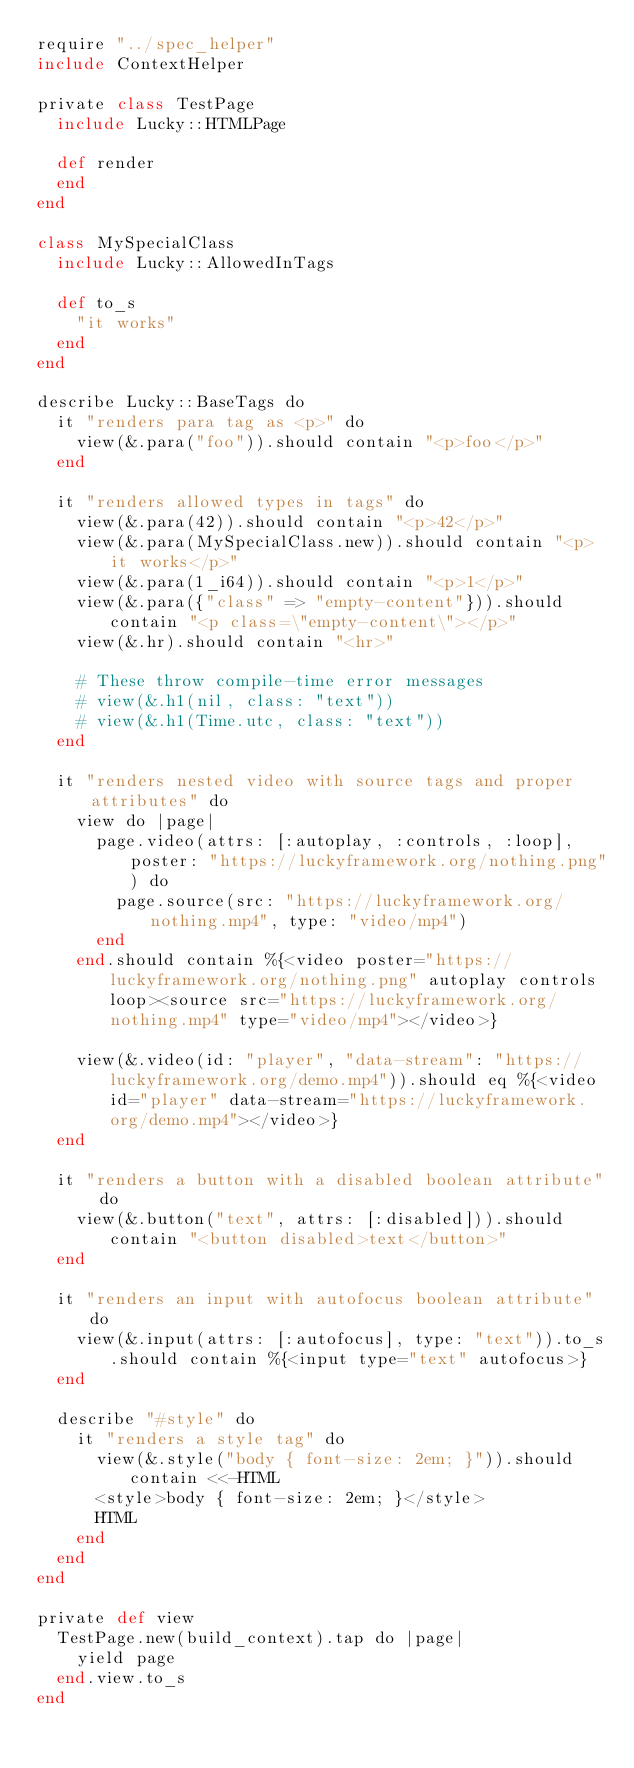<code> <loc_0><loc_0><loc_500><loc_500><_Crystal_>require "../spec_helper"
include ContextHelper

private class TestPage
  include Lucky::HTMLPage

  def render
  end
end

class MySpecialClass
  include Lucky::AllowedInTags

  def to_s
    "it works"
  end
end

describe Lucky::BaseTags do
  it "renders para tag as <p>" do
    view(&.para("foo")).should contain "<p>foo</p>"
  end

  it "renders allowed types in tags" do
    view(&.para(42)).should contain "<p>42</p>"
    view(&.para(MySpecialClass.new)).should contain "<p>it works</p>"
    view(&.para(1_i64)).should contain "<p>1</p>"
    view(&.para({"class" => "empty-content"})).should contain "<p class=\"empty-content\"></p>"
    view(&.hr).should contain "<hr>"

    # These throw compile-time error messages
    # view(&.h1(nil, class: "text"))
    # view(&.h1(Time.utc, class: "text"))
  end

  it "renders nested video with source tags and proper attributes" do
    view do |page|
      page.video(attrs: [:autoplay, :controls, :loop], poster: "https://luckyframework.org/nothing.png") do
        page.source(src: "https://luckyframework.org/nothing.mp4", type: "video/mp4")
      end
    end.should contain %{<video poster="https://luckyframework.org/nothing.png" autoplay controls loop><source src="https://luckyframework.org/nothing.mp4" type="video/mp4"></video>}

    view(&.video(id: "player", "data-stream": "https://luckyframework.org/demo.mp4")).should eq %{<video id="player" data-stream="https://luckyframework.org/demo.mp4"></video>}
  end

  it "renders a button with a disabled boolean attribute" do
    view(&.button("text", attrs: [:disabled])).should contain "<button disabled>text</button>"
  end

  it "renders an input with autofocus boolean attribute" do
    view(&.input(attrs: [:autofocus], type: "text")).to_s.should contain %{<input type="text" autofocus>}
  end

  describe "#style" do
    it "renders a style tag" do
      view(&.style("body { font-size: 2em; }")).should contain <<-HTML
      <style>body { font-size: 2em; }</style>
      HTML
    end
  end
end

private def view
  TestPage.new(build_context).tap do |page|
    yield page
  end.view.to_s
end
</code> 